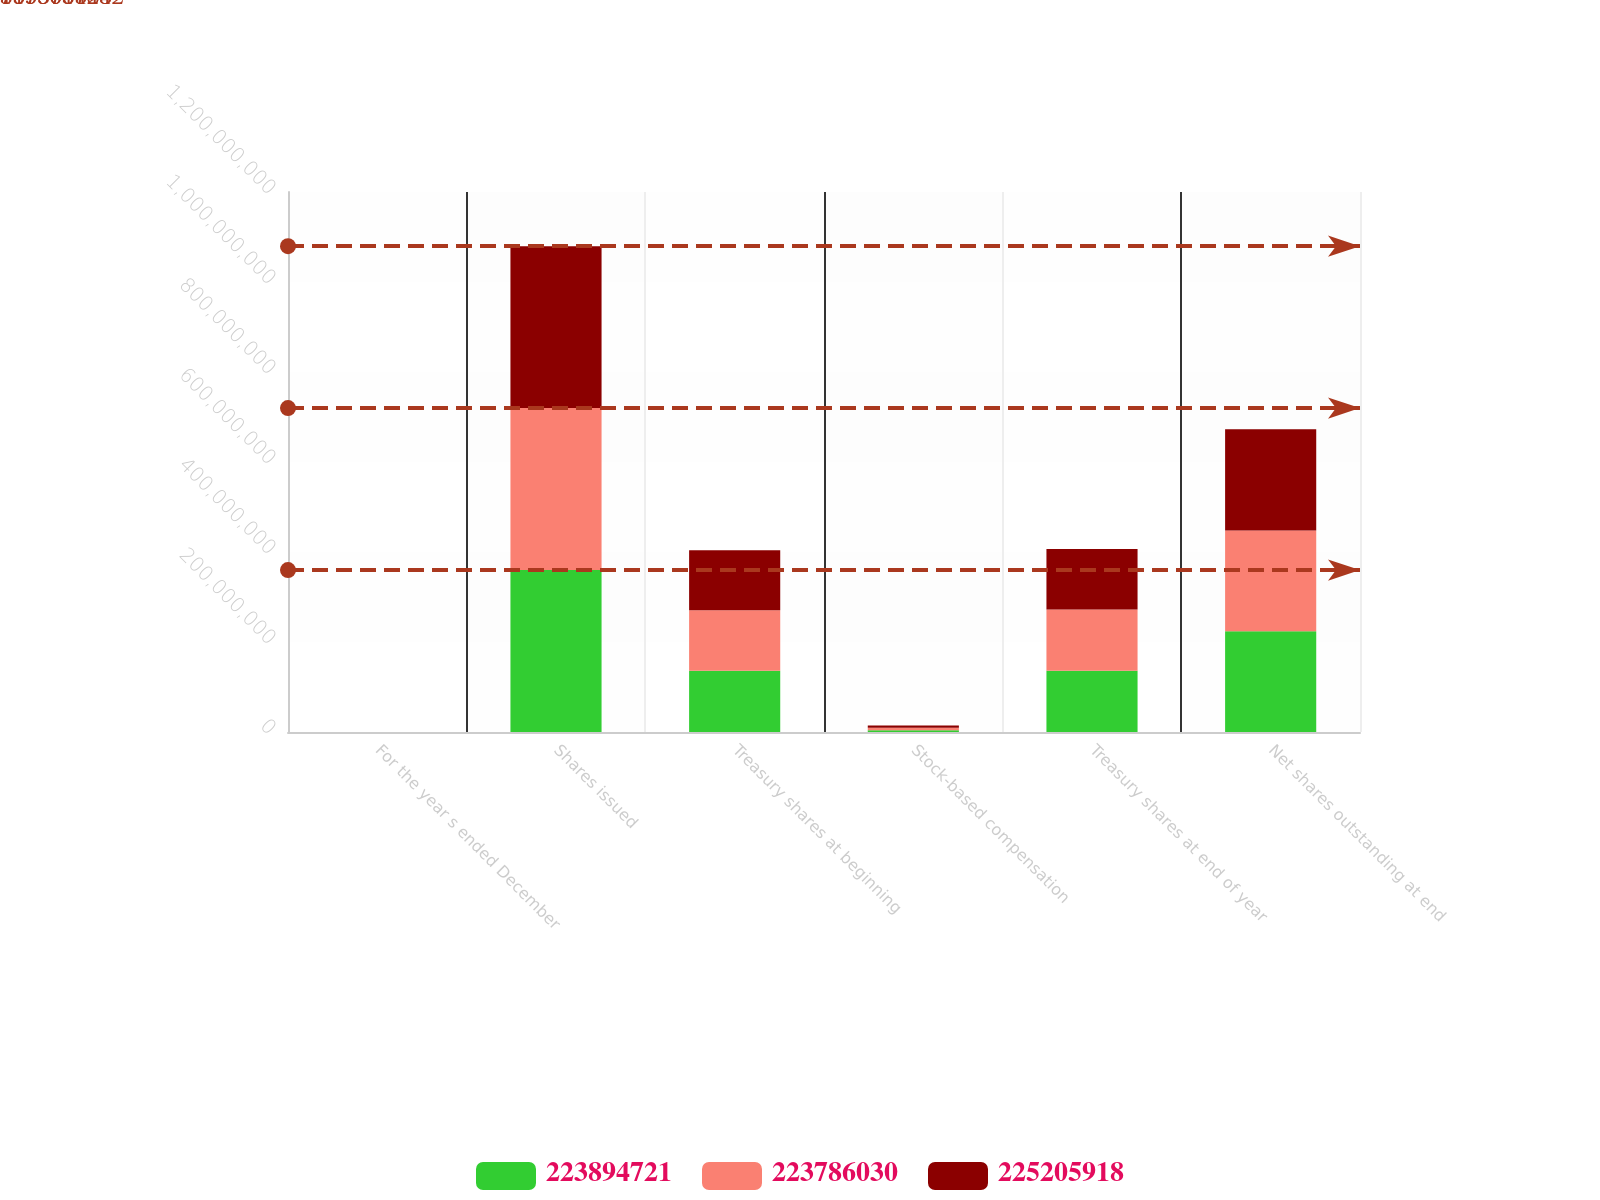Convert chart to OTSL. <chart><loc_0><loc_0><loc_500><loc_500><stacked_bar_chart><ecel><fcel>For the year s ended December<fcel>Shares issued<fcel>Treasury shares at beginning<fcel>Stock-based compensation<fcel>Treasury shares at end of year<fcel>Net shares outstanding at end<nl><fcel>2.23895e+08<fcel>2013<fcel>3.59902e+08<fcel>1.36116e+08<fcel>3.65583e+06<fcel>1.36007e+08<fcel>2.23895e+08<nl><fcel>2.23786e+08<fcel>2012<fcel>3.59902e+08<fcel>1.34696e+08<fcel>5.59854e+06<fcel>1.36116e+08<fcel>2.23786e+08<nl><fcel>2.25206e+08<fcel>2011<fcel>3.59902e+08<fcel>1.32872e+08<fcel>5.17903e+06<fcel>1.34696e+08<fcel>2.25206e+08<nl></chart> 